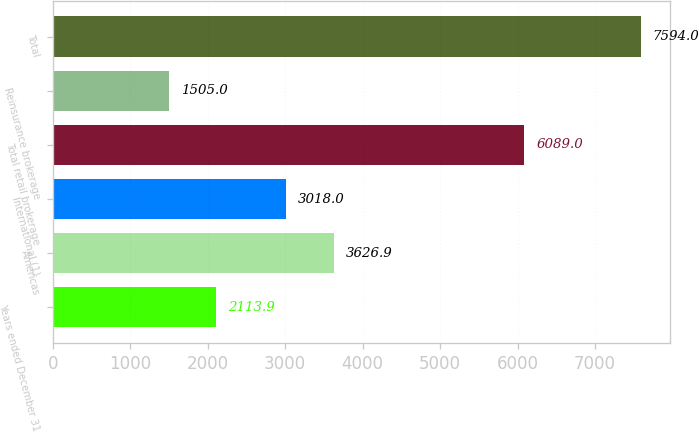<chart> <loc_0><loc_0><loc_500><loc_500><bar_chart><fcel>Years ended December 31<fcel>Americas<fcel>International (1)<fcel>Total retail brokerage<fcel>Reinsurance brokerage<fcel>Total<nl><fcel>2113.9<fcel>3626.9<fcel>3018<fcel>6089<fcel>1505<fcel>7594<nl></chart> 